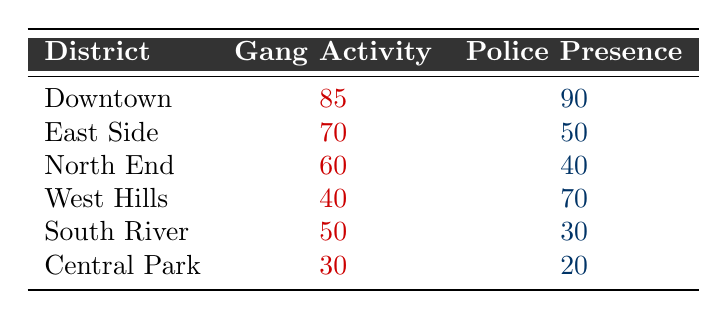What's the gang activity level in Downtown? The table shows that the gang activity level in Downtown is 85.
Answer: 85 What is the police presence in the East Side? According to the table, the police presence in the East Side is 50.
Answer: 50 Which district has the highest gang activity? The district with the highest gang activity is Downtown with a score of 85.
Answer: Downtown What is the difference between gang activity in the South River and the North End? The gang activity in South River is 50, and in North End, it's 60. The difference is 60 - 50 = 10.
Answer: 10 Is the police presence higher in Central Park than in West Hills? The police presence in Central Park is 20, while in West Hills, it is 70. So, no, it is not higher.
Answer: No What is the average gang activity across all districts? The gang activity scores are 85, 70, 60, 40, 50, and 30. The sum is 85 + 70 + 60 + 40 + 50 + 30 = 335. There are 6 districts, so the average is 335 / 6 ≈ 55.83.
Answer: 55.83 Which district exhibits the least gang activity? The least gang activity is noted in Central Park, with a score of 30.
Answer: Central Park Is there a correlation between high police presence and low gang activity in this data? In the table, we can see that as police presence increases, gang activity tends to decrease in some cases. For example, Downtown has high activity but also high police presence, while Central Park has low activity and low police presence. This suggests a potential correlation, but more analysis would be needed for confirmation.
Answer: Yes, potential correlation exists What is the total gang activity in districts with police presence greater than 50? The districts with police presence greater than 50 are Downtown (85), East Side (70), and West Hills (40). Therefore, the total is 85 + 70 + 40 = 195.
Answer: 195 